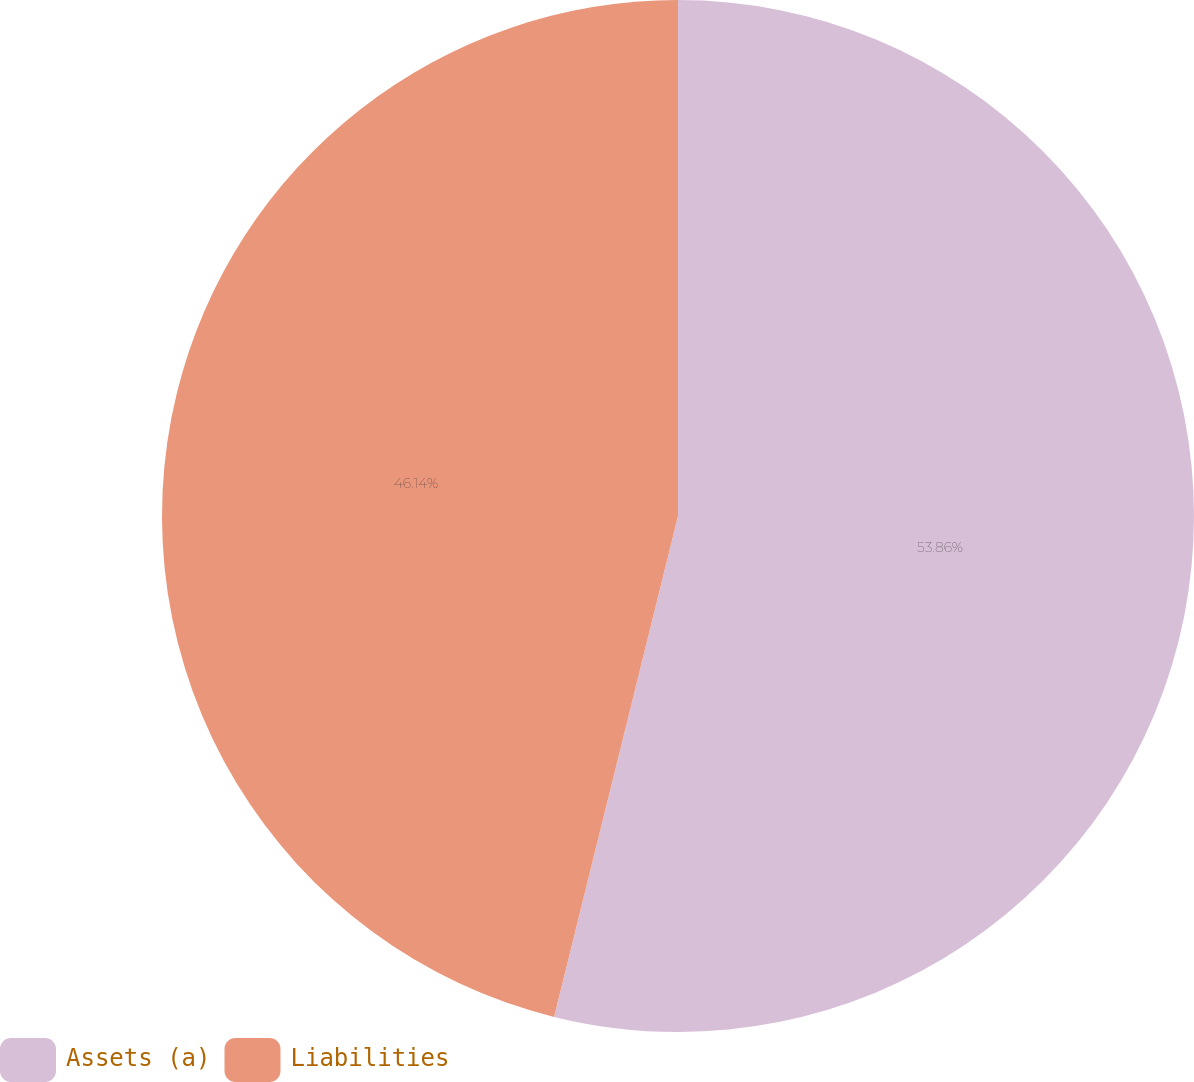Convert chart. <chart><loc_0><loc_0><loc_500><loc_500><pie_chart><fcel>Assets (a)<fcel>Liabilities<nl><fcel>53.86%<fcel>46.14%<nl></chart> 